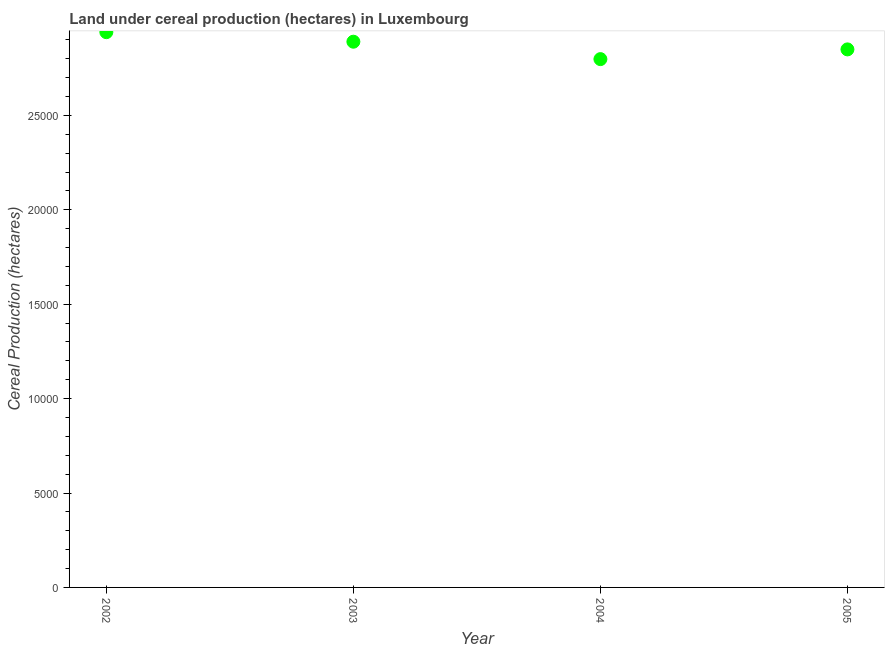What is the land under cereal production in 2005?
Make the answer very short. 2.85e+04. Across all years, what is the maximum land under cereal production?
Your answer should be compact. 2.94e+04. Across all years, what is the minimum land under cereal production?
Your answer should be very brief. 2.80e+04. In which year was the land under cereal production maximum?
Your response must be concise. 2002. What is the sum of the land under cereal production?
Provide a short and direct response. 1.15e+05. What is the difference between the land under cereal production in 2004 and 2005?
Keep it short and to the point. -515. What is the average land under cereal production per year?
Ensure brevity in your answer.  2.87e+04. What is the median land under cereal production?
Offer a very short reply. 2.87e+04. In how many years, is the land under cereal production greater than 21000 hectares?
Offer a very short reply. 4. What is the ratio of the land under cereal production in 2003 to that in 2004?
Your answer should be compact. 1.03. Is the land under cereal production in 2002 less than that in 2004?
Provide a short and direct response. No. Is the difference between the land under cereal production in 2004 and 2005 greater than the difference between any two years?
Keep it short and to the point. No. What is the difference between the highest and the second highest land under cereal production?
Ensure brevity in your answer.  505. What is the difference between the highest and the lowest land under cereal production?
Provide a short and direct response. 1427. How many dotlines are there?
Provide a succinct answer. 1. How many years are there in the graph?
Make the answer very short. 4. What is the difference between two consecutive major ticks on the Y-axis?
Ensure brevity in your answer.  5000. Does the graph contain grids?
Make the answer very short. No. What is the title of the graph?
Ensure brevity in your answer.  Land under cereal production (hectares) in Luxembourg. What is the label or title of the X-axis?
Offer a terse response. Year. What is the label or title of the Y-axis?
Offer a very short reply. Cereal Production (hectares). What is the Cereal Production (hectares) in 2002?
Your answer should be compact. 2.94e+04. What is the Cereal Production (hectares) in 2003?
Your answer should be very brief. 2.89e+04. What is the Cereal Production (hectares) in 2004?
Keep it short and to the point. 2.80e+04. What is the Cereal Production (hectares) in 2005?
Offer a very short reply. 2.85e+04. What is the difference between the Cereal Production (hectares) in 2002 and 2003?
Your answer should be compact. 505. What is the difference between the Cereal Production (hectares) in 2002 and 2004?
Offer a terse response. 1427. What is the difference between the Cereal Production (hectares) in 2002 and 2005?
Keep it short and to the point. 912. What is the difference between the Cereal Production (hectares) in 2003 and 2004?
Your response must be concise. 922. What is the difference between the Cereal Production (hectares) in 2003 and 2005?
Your response must be concise. 407. What is the difference between the Cereal Production (hectares) in 2004 and 2005?
Your answer should be compact. -515. What is the ratio of the Cereal Production (hectares) in 2002 to that in 2003?
Your answer should be very brief. 1.02. What is the ratio of the Cereal Production (hectares) in 2002 to that in 2004?
Give a very brief answer. 1.05. What is the ratio of the Cereal Production (hectares) in 2002 to that in 2005?
Your response must be concise. 1.03. What is the ratio of the Cereal Production (hectares) in 2003 to that in 2004?
Offer a terse response. 1.03. What is the ratio of the Cereal Production (hectares) in 2003 to that in 2005?
Provide a short and direct response. 1.01. What is the ratio of the Cereal Production (hectares) in 2004 to that in 2005?
Your answer should be compact. 0.98. 